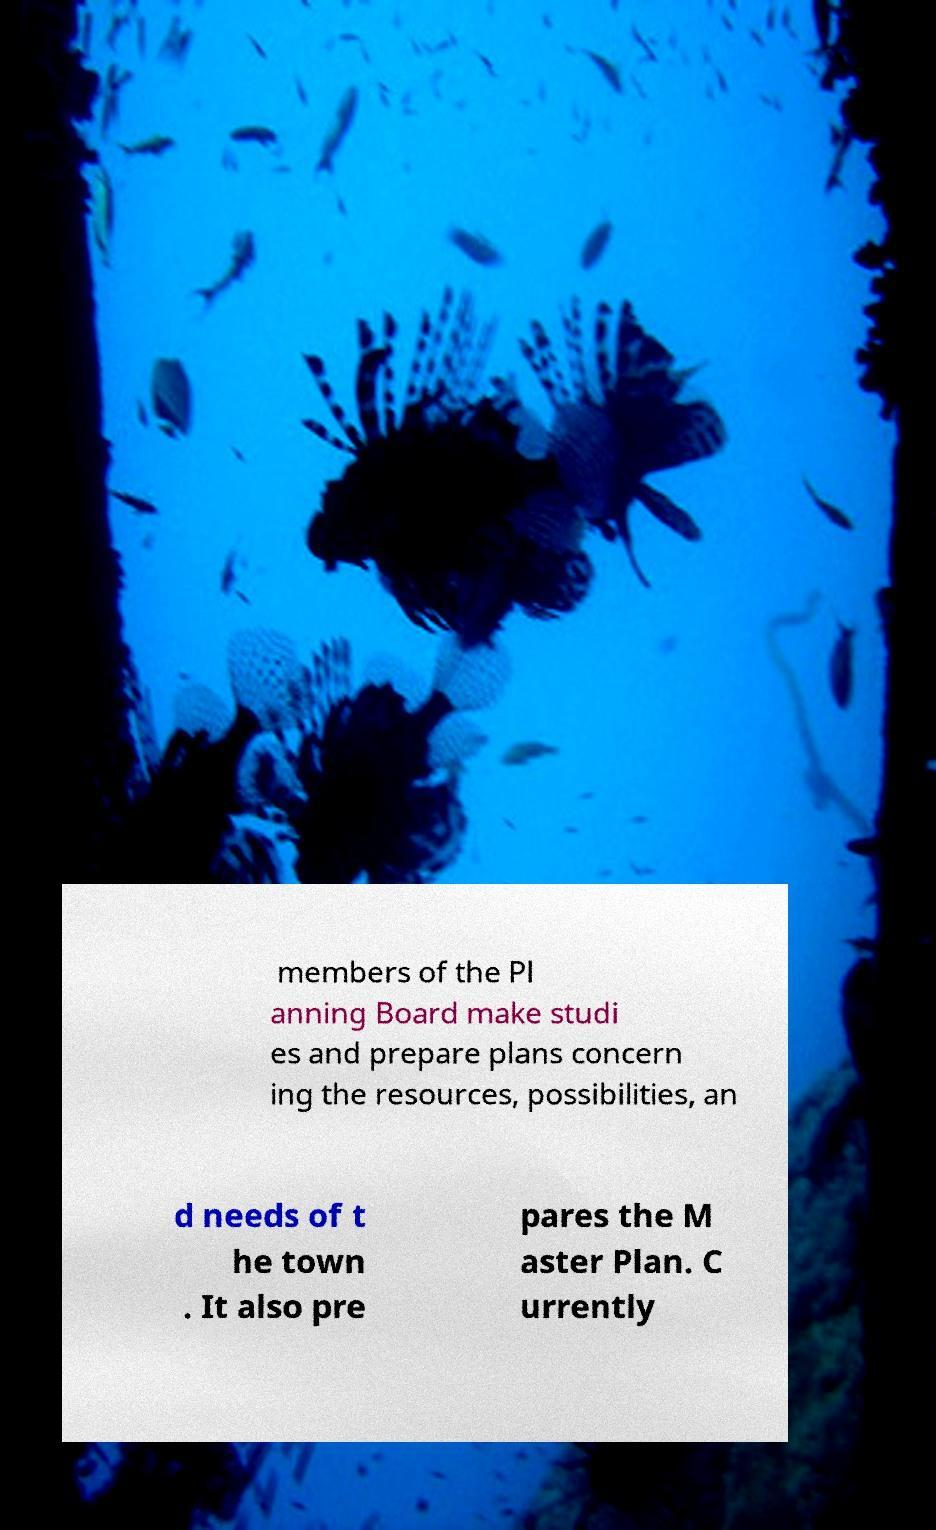There's text embedded in this image that I need extracted. Can you transcribe it verbatim? members of the Pl anning Board make studi es and prepare plans concern ing the resources, possibilities, an d needs of t he town . It also pre pares the M aster Plan. C urrently 